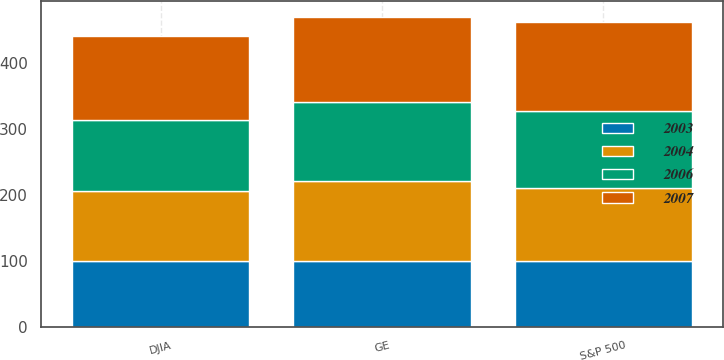<chart> <loc_0><loc_0><loc_500><loc_500><stacked_bar_chart><ecel><fcel>GE<fcel>S&P 500<fcel>DJIA<nl><fcel>2003<fcel>100<fcel>100<fcel>100<nl><fcel>2004<fcel>121<fcel>111<fcel>106<nl><fcel>2006<fcel>119<fcel>116<fcel>107<nl><fcel>2007<fcel>130<fcel>135<fcel>128<nl></chart> 